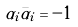Convert formula to latex. <formula><loc_0><loc_0><loc_500><loc_500>\alpha _ { i } { \bar { \alpha } } _ { i } = - 1</formula> 